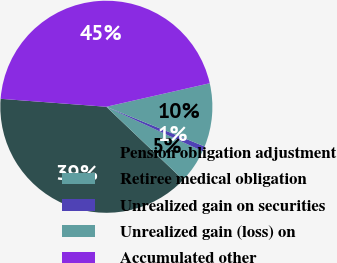Convert chart. <chart><loc_0><loc_0><loc_500><loc_500><pie_chart><fcel>Pension obligation adjustment<fcel>Retiree medical obligation<fcel>Unrealized gain on securities<fcel>Unrealized gain (loss) on<fcel>Accumulated other<nl><fcel>39.08%<fcel>5.22%<fcel>0.78%<fcel>9.67%<fcel>45.24%<nl></chart> 